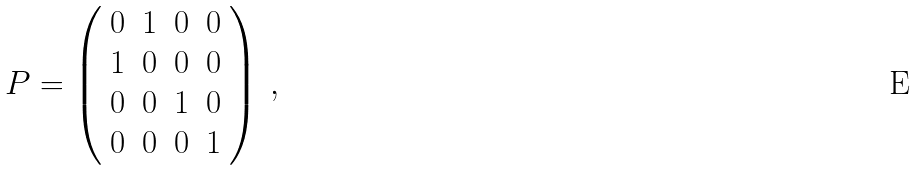Convert formula to latex. <formula><loc_0><loc_0><loc_500><loc_500>P = \left ( \begin{array} { c c c c } 0 & 1 & 0 & 0 \\ 1 & 0 & 0 & 0 \\ 0 & 0 & 1 & 0 \\ 0 & 0 & 0 & 1 \end{array} \right ) \, ,</formula> 